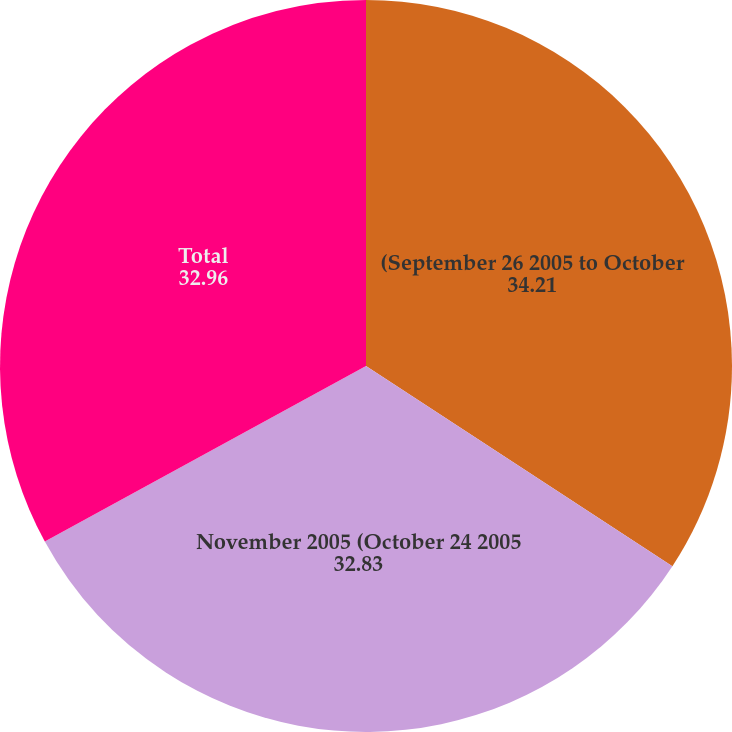Convert chart. <chart><loc_0><loc_0><loc_500><loc_500><pie_chart><fcel>(September 26 2005 to October<fcel>November 2005 (October 24 2005<fcel>Total<nl><fcel>34.21%<fcel>32.83%<fcel>32.96%<nl></chart> 